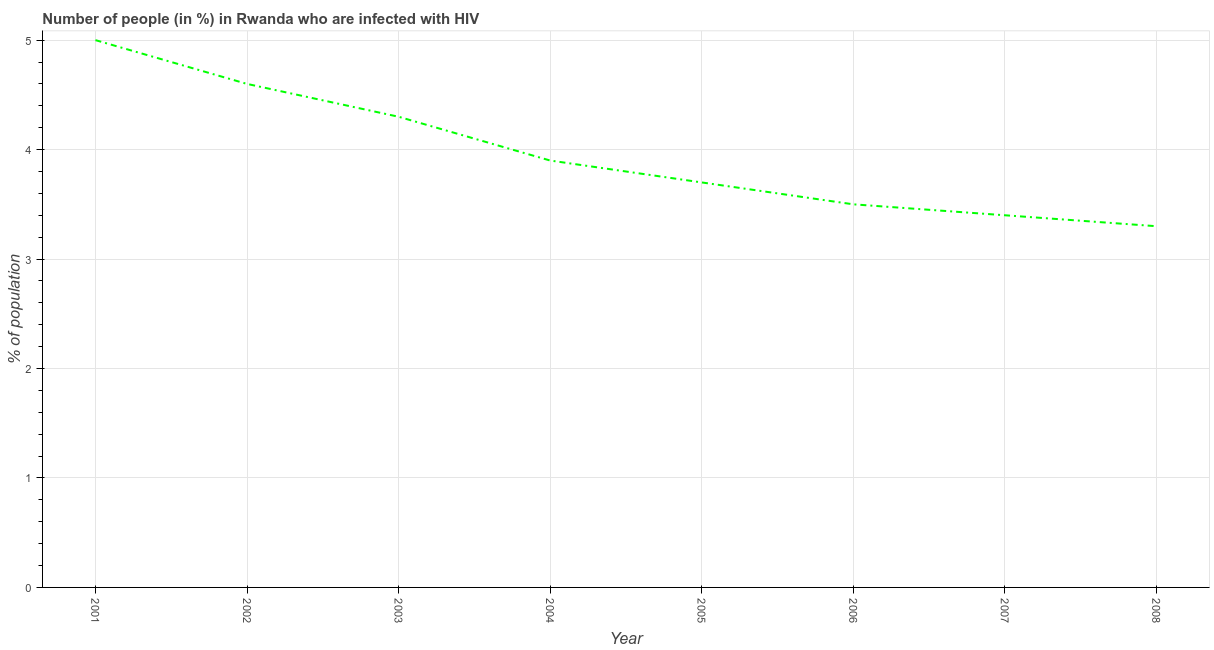What is the sum of the number of people infected with hiv?
Your answer should be compact. 31.7. What is the difference between the number of people infected with hiv in 2005 and 2008?
Your answer should be very brief. 0.4. What is the average number of people infected with hiv per year?
Your answer should be very brief. 3.96. What is the median number of people infected with hiv?
Provide a short and direct response. 3.8. In how many years, is the number of people infected with hiv greater than 2.4 %?
Offer a terse response. 8. Do a majority of the years between 2004 and 2007 (inclusive) have number of people infected with hiv greater than 3 %?
Your answer should be very brief. Yes. What is the ratio of the number of people infected with hiv in 2002 to that in 2007?
Offer a very short reply. 1.35. Is the difference between the number of people infected with hiv in 2002 and 2004 greater than the difference between any two years?
Ensure brevity in your answer.  No. What is the difference between the highest and the second highest number of people infected with hiv?
Ensure brevity in your answer.  0.4. What is the difference between the highest and the lowest number of people infected with hiv?
Provide a succinct answer. 1.7. In how many years, is the number of people infected with hiv greater than the average number of people infected with hiv taken over all years?
Your answer should be very brief. 3. What is the title of the graph?
Your answer should be very brief. Number of people (in %) in Rwanda who are infected with HIV. What is the label or title of the Y-axis?
Make the answer very short. % of population. What is the % of population in 2003?
Offer a terse response. 4.3. What is the % of population of 2006?
Give a very brief answer. 3.5. What is the difference between the % of population in 2001 and 2003?
Provide a succinct answer. 0.7. What is the difference between the % of population in 2001 and 2004?
Provide a short and direct response. 1.1. What is the difference between the % of population in 2001 and 2006?
Provide a succinct answer. 1.5. What is the difference between the % of population in 2001 and 2008?
Offer a very short reply. 1.7. What is the difference between the % of population in 2002 and 2003?
Offer a very short reply. 0.3. What is the difference between the % of population in 2002 and 2004?
Provide a short and direct response. 0.7. What is the difference between the % of population in 2002 and 2005?
Offer a very short reply. 0.9. What is the difference between the % of population in 2002 and 2006?
Keep it short and to the point. 1.1. What is the difference between the % of population in 2002 and 2007?
Offer a very short reply. 1.2. What is the difference between the % of population in 2002 and 2008?
Your response must be concise. 1.3. What is the difference between the % of population in 2003 and 2005?
Keep it short and to the point. 0.6. What is the difference between the % of population in 2004 and 2006?
Your response must be concise. 0.4. What is the difference between the % of population in 2004 and 2007?
Ensure brevity in your answer.  0.5. What is the difference between the % of population in 2005 and 2006?
Make the answer very short. 0.2. What is the difference between the % of population in 2005 and 2007?
Give a very brief answer. 0.3. What is the difference between the % of population in 2006 and 2008?
Your answer should be very brief. 0.2. What is the difference between the % of population in 2007 and 2008?
Keep it short and to the point. 0.1. What is the ratio of the % of population in 2001 to that in 2002?
Your answer should be very brief. 1.09. What is the ratio of the % of population in 2001 to that in 2003?
Give a very brief answer. 1.16. What is the ratio of the % of population in 2001 to that in 2004?
Your response must be concise. 1.28. What is the ratio of the % of population in 2001 to that in 2005?
Give a very brief answer. 1.35. What is the ratio of the % of population in 2001 to that in 2006?
Provide a short and direct response. 1.43. What is the ratio of the % of population in 2001 to that in 2007?
Keep it short and to the point. 1.47. What is the ratio of the % of population in 2001 to that in 2008?
Provide a succinct answer. 1.51. What is the ratio of the % of population in 2002 to that in 2003?
Give a very brief answer. 1.07. What is the ratio of the % of population in 2002 to that in 2004?
Offer a terse response. 1.18. What is the ratio of the % of population in 2002 to that in 2005?
Your answer should be very brief. 1.24. What is the ratio of the % of population in 2002 to that in 2006?
Your answer should be very brief. 1.31. What is the ratio of the % of population in 2002 to that in 2007?
Your answer should be compact. 1.35. What is the ratio of the % of population in 2002 to that in 2008?
Give a very brief answer. 1.39. What is the ratio of the % of population in 2003 to that in 2004?
Make the answer very short. 1.1. What is the ratio of the % of population in 2003 to that in 2005?
Your answer should be compact. 1.16. What is the ratio of the % of population in 2003 to that in 2006?
Make the answer very short. 1.23. What is the ratio of the % of population in 2003 to that in 2007?
Your answer should be very brief. 1.26. What is the ratio of the % of population in 2003 to that in 2008?
Offer a terse response. 1.3. What is the ratio of the % of population in 2004 to that in 2005?
Your answer should be very brief. 1.05. What is the ratio of the % of population in 2004 to that in 2006?
Your answer should be very brief. 1.11. What is the ratio of the % of population in 2004 to that in 2007?
Ensure brevity in your answer.  1.15. What is the ratio of the % of population in 2004 to that in 2008?
Provide a succinct answer. 1.18. What is the ratio of the % of population in 2005 to that in 2006?
Your answer should be compact. 1.06. What is the ratio of the % of population in 2005 to that in 2007?
Offer a terse response. 1.09. What is the ratio of the % of population in 2005 to that in 2008?
Offer a very short reply. 1.12. What is the ratio of the % of population in 2006 to that in 2008?
Provide a short and direct response. 1.06. 